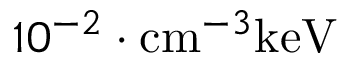Convert formula to latex. <formula><loc_0><loc_0><loc_500><loc_500>1 0 ^ { - 2 } \cdot c m ^ { - 3 } k e V</formula> 